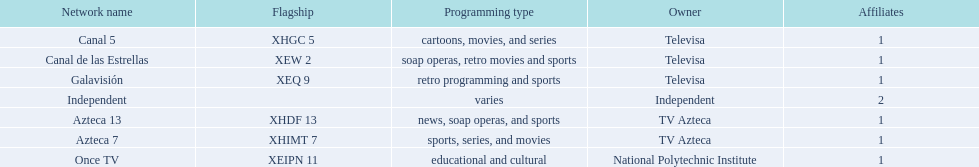Who is the only network owner listed in a consecutive order in the chart? Televisa. 